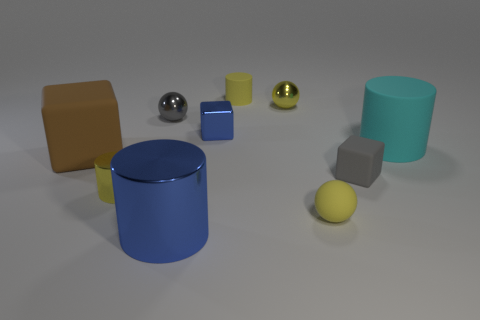Subtract all purple cylinders. Subtract all gray balls. How many cylinders are left? 4 Subtract all cylinders. How many objects are left? 6 Add 10 large gray rubber spheres. How many large gray rubber spheres exist? 10 Subtract 0 red cylinders. How many objects are left? 10 Subtract all yellow balls. Subtract all tiny gray shiny balls. How many objects are left? 7 Add 4 small gray spheres. How many small gray spheres are left? 5 